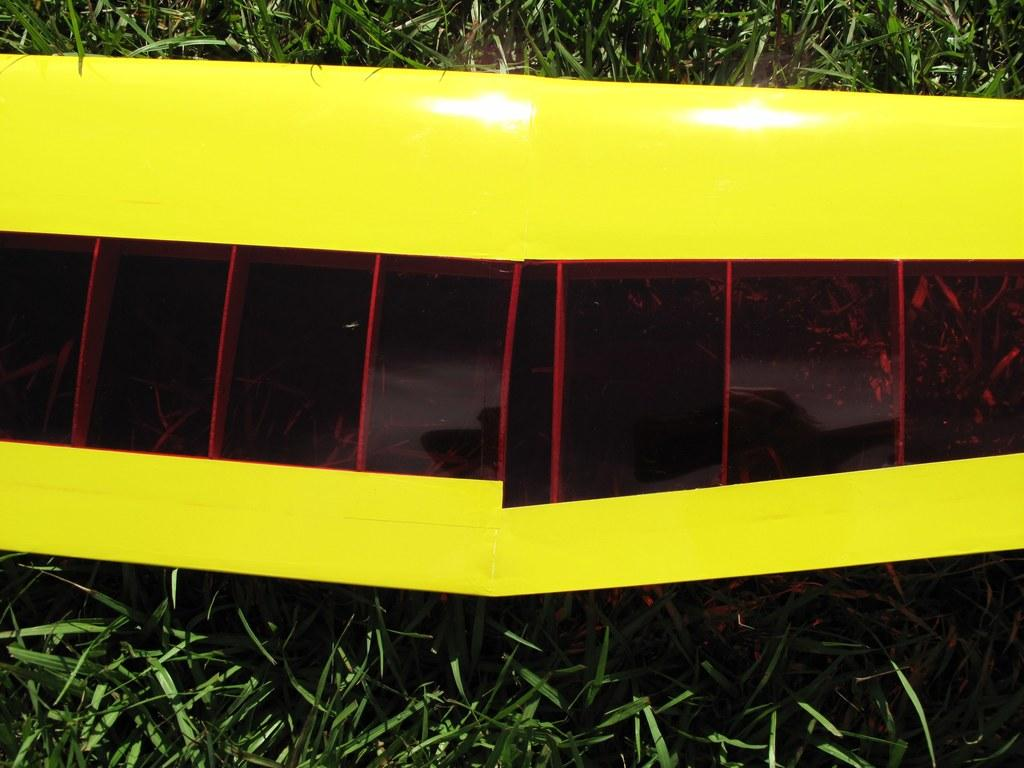What colors are the frames in the image? There is a yellow color frame and a red color frame in the image. Where are the frames located? The frames are on grass. What flavor of ice cream does the partner enjoy while sitting on the grass? There is no partner or ice cream mentioned in the image, so we cannot determine the flavor of ice cream they might enjoy. 